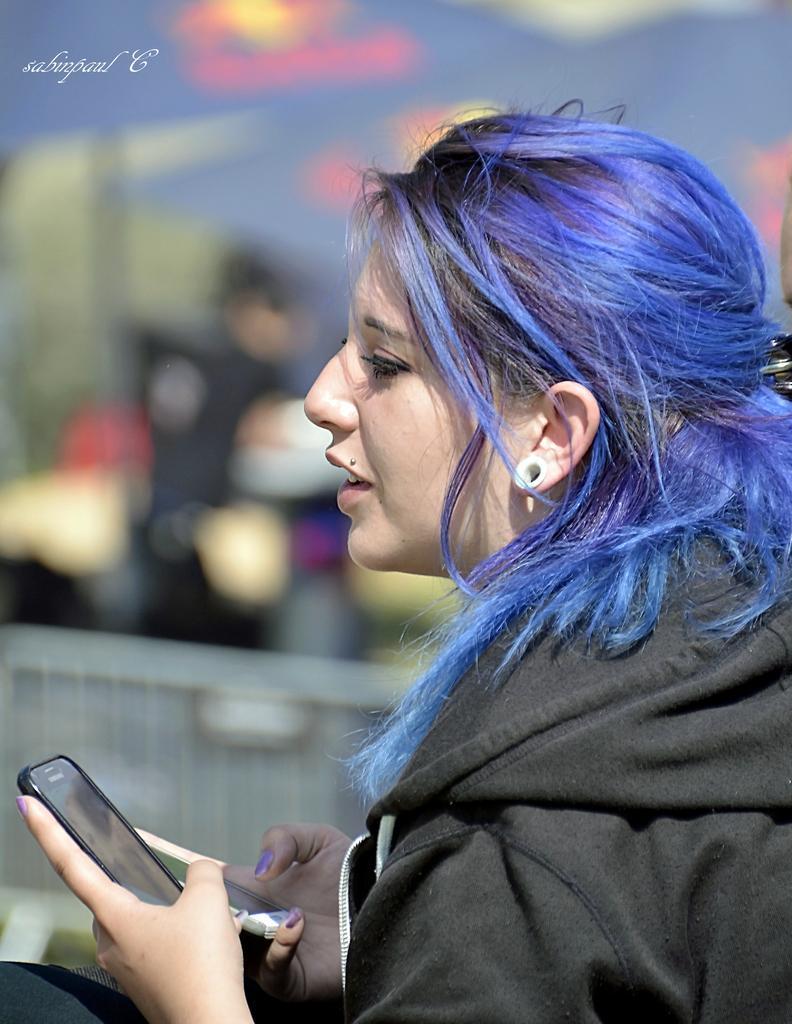Describe this image in one or two sentences. In this picture here is a woman, she is wearing a black color jacket, and with blue color hair, she is smiling, and she is holding a phone in her hand. and here it is a sky. 